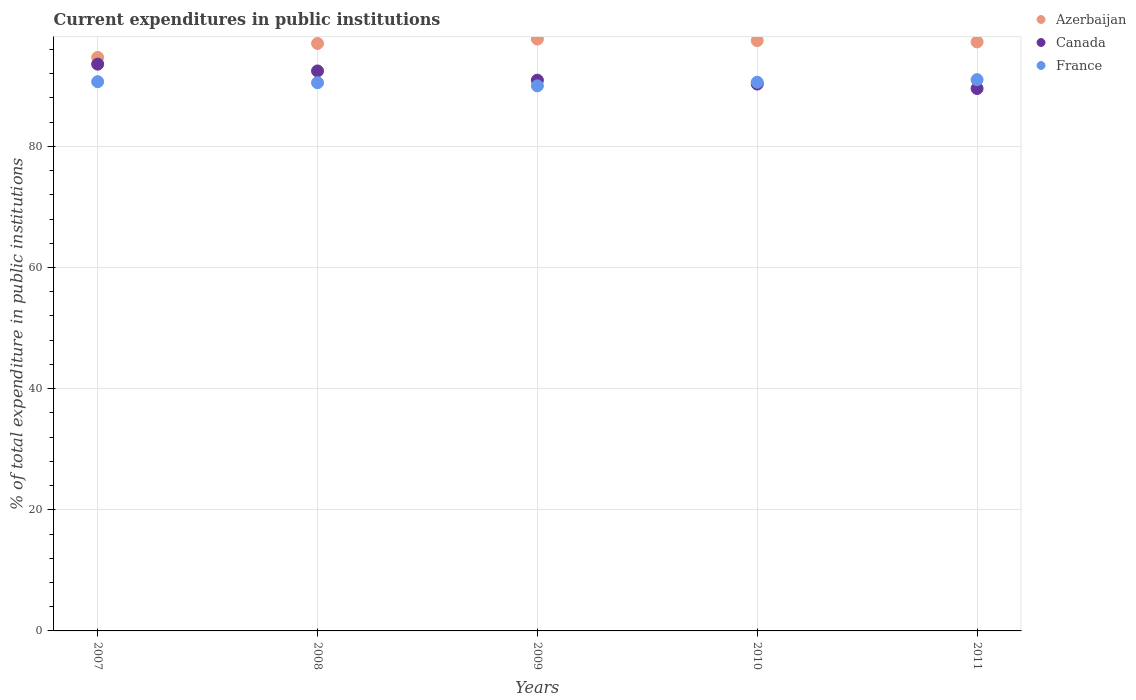Is the number of dotlines equal to the number of legend labels?
Give a very brief answer. Yes. What is the current expenditures in public institutions in Canada in 2008?
Your response must be concise. 92.45. Across all years, what is the maximum current expenditures in public institutions in Canada?
Keep it short and to the point. 93.57. Across all years, what is the minimum current expenditures in public institutions in Canada?
Offer a terse response. 89.55. What is the total current expenditures in public institutions in Canada in the graph?
Keep it short and to the point. 456.79. What is the difference between the current expenditures in public institutions in France in 2008 and that in 2011?
Your answer should be compact. -0.5. What is the difference between the current expenditures in public institutions in France in 2011 and the current expenditures in public institutions in Canada in 2010?
Provide a succinct answer. 0.72. What is the average current expenditures in public institutions in France per year?
Keep it short and to the point. 90.56. In the year 2008, what is the difference between the current expenditures in public institutions in France and current expenditures in public institutions in Azerbaijan?
Your answer should be compact. -6.48. In how many years, is the current expenditures in public institutions in France greater than 68 %?
Your response must be concise. 5. What is the ratio of the current expenditures in public institutions in Canada in 2007 to that in 2009?
Make the answer very short. 1.03. Is the current expenditures in public institutions in France in 2008 less than that in 2009?
Your answer should be very brief. No. Is the difference between the current expenditures in public institutions in France in 2010 and 2011 greater than the difference between the current expenditures in public institutions in Azerbaijan in 2010 and 2011?
Provide a succinct answer. No. What is the difference between the highest and the second highest current expenditures in public institutions in Canada?
Ensure brevity in your answer.  1.12. What is the difference between the highest and the lowest current expenditures in public institutions in Canada?
Give a very brief answer. 4.02. In how many years, is the current expenditures in public institutions in Canada greater than the average current expenditures in public institutions in Canada taken over all years?
Make the answer very short. 2. Is it the case that in every year, the sum of the current expenditures in public institutions in France and current expenditures in public institutions in Azerbaijan  is greater than the current expenditures in public institutions in Canada?
Your answer should be compact. Yes. Does the current expenditures in public institutions in Azerbaijan monotonically increase over the years?
Your response must be concise. No. Is the current expenditures in public institutions in France strictly less than the current expenditures in public institutions in Canada over the years?
Keep it short and to the point. No. How many years are there in the graph?
Offer a very short reply. 5. What is the difference between two consecutive major ticks on the Y-axis?
Offer a very short reply. 20. Where does the legend appear in the graph?
Keep it short and to the point. Top right. How many legend labels are there?
Your answer should be very brief. 3. How are the legend labels stacked?
Offer a terse response. Vertical. What is the title of the graph?
Provide a succinct answer. Current expenditures in public institutions. Does "Lesotho" appear as one of the legend labels in the graph?
Offer a terse response. No. What is the label or title of the X-axis?
Ensure brevity in your answer.  Years. What is the label or title of the Y-axis?
Ensure brevity in your answer.  % of total expenditure in public institutions. What is the % of total expenditure in public institutions in Azerbaijan in 2007?
Offer a terse response. 94.68. What is the % of total expenditure in public institutions in Canada in 2007?
Provide a succinct answer. 93.57. What is the % of total expenditure in public institutions in France in 2007?
Ensure brevity in your answer.  90.67. What is the % of total expenditure in public institutions in Azerbaijan in 2008?
Make the answer very short. 96.99. What is the % of total expenditure in public institutions in Canada in 2008?
Provide a succinct answer. 92.45. What is the % of total expenditure in public institutions in France in 2008?
Your answer should be compact. 90.51. What is the % of total expenditure in public institutions of Azerbaijan in 2009?
Offer a very short reply. 97.72. What is the % of total expenditure in public institutions of Canada in 2009?
Your answer should be very brief. 90.93. What is the % of total expenditure in public institutions in France in 2009?
Your response must be concise. 89.99. What is the % of total expenditure in public institutions of Azerbaijan in 2010?
Keep it short and to the point. 97.46. What is the % of total expenditure in public institutions in Canada in 2010?
Provide a succinct answer. 90.29. What is the % of total expenditure in public institutions in France in 2010?
Keep it short and to the point. 90.59. What is the % of total expenditure in public institutions of Azerbaijan in 2011?
Keep it short and to the point. 97.25. What is the % of total expenditure in public institutions of Canada in 2011?
Offer a terse response. 89.55. What is the % of total expenditure in public institutions in France in 2011?
Give a very brief answer. 91.01. Across all years, what is the maximum % of total expenditure in public institutions in Azerbaijan?
Provide a short and direct response. 97.72. Across all years, what is the maximum % of total expenditure in public institutions in Canada?
Offer a very short reply. 93.57. Across all years, what is the maximum % of total expenditure in public institutions of France?
Your answer should be compact. 91.01. Across all years, what is the minimum % of total expenditure in public institutions in Azerbaijan?
Provide a short and direct response. 94.68. Across all years, what is the minimum % of total expenditure in public institutions of Canada?
Provide a succinct answer. 89.55. Across all years, what is the minimum % of total expenditure in public institutions of France?
Your response must be concise. 89.99. What is the total % of total expenditure in public institutions in Azerbaijan in the graph?
Your answer should be very brief. 484.1. What is the total % of total expenditure in public institutions of Canada in the graph?
Give a very brief answer. 456.79. What is the total % of total expenditure in public institutions of France in the graph?
Provide a short and direct response. 452.78. What is the difference between the % of total expenditure in public institutions in Azerbaijan in 2007 and that in 2008?
Make the answer very short. -2.31. What is the difference between the % of total expenditure in public institutions in Canada in 2007 and that in 2008?
Offer a terse response. 1.12. What is the difference between the % of total expenditure in public institutions of France in 2007 and that in 2008?
Your answer should be compact. 0.17. What is the difference between the % of total expenditure in public institutions of Azerbaijan in 2007 and that in 2009?
Ensure brevity in your answer.  -3.04. What is the difference between the % of total expenditure in public institutions of Canada in 2007 and that in 2009?
Make the answer very short. 2.65. What is the difference between the % of total expenditure in public institutions in France in 2007 and that in 2009?
Offer a terse response. 0.68. What is the difference between the % of total expenditure in public institutions of Azerbaijan in 2007 and that in 2010?
Ensure brevity in your answer.  -2.78. What is the difference between the % of total expenditure in public institutions in Canada in 2007 and that in 2010?
Offer a very short reply. 3.28. What is the difference between the % of total expenditure in public institutions of France in 2007 and that in 2010?
Keep it short and to the point. 0.08. What is the difference between the % of total expenditure in public institutions in Azerbaijan in 2007 and that in 2011?
Keep it short and to the point. -2.57. What is the difference between the % of total expenditure in public institutions in Canada in 2007 and that in 2011?
Provide a short and direct response. 4.02. What is the difference between the % of total expenditure in public institutions in France in 2007 and that in 2011?
Keep it short and to the point. -0.34. What is the difference between the % of total expenditure in public institutions of Azerbaijan in 2008 and that in 2009?
Keep it short and to the point. -0.73. What is the difference between the % of total expenditure in public institutions in Canada in 2008 and that in 2009?
Your answer should be compact. 1.52. What is the difference between the % of total expenditure in public institutions in France in 2008 and that in 2009?
Provide a succinct answer. 0.52. What is the difference between the % of total expenditure in public institutions of Azerbaijan in 2008 and that in 2010?
Provide a short and direct response. -0.48. What is the difference between the % of total expenditure in public institutions of Canada in 2008 and that in 2010?
Offer a very short reply. 2.16. What is the difference between the % of total expenditure in public institutions in France in 2008 and that in 2010?
Provide a succinct answer. -0.08. What is the difference between the % of total expenditure in public institutions in Azerbaijan in 2008 and that in 2011?
Offer a very short reply. -0.26. What is the difference between the % of total expenditure in public institutions in Canada in 2008 and that in 2011?
Your answer should be very brief. 2.9. What is the difference between the % of total expenditure in public institutions in France in 2008 and that in 2011?
Keep it short and to the point. -0.5. What is the difference between the % of total expenditure in public institutions of Azerbaijan in 2009 and that in 2010?
Offer a very short reply. 0.25. What is the difference between the % of total expenditure in public institutions of Canada in 2009 and that in 2010?
Make the answer very short. 0.64. What is the difference between the % of total expenditure in public institutions of France in 2009 and that in 2010?
Your answer should be very brief. -0.6. What is the difference between the % of total expenditure in public institutions of Azerbaijan in 2009 and that in 2011?
Your answer should be compact. 0.47. What is the difference between the % of total expenditure in public institutions in Canada in 2009 and that in 2011?
Provide a short and direct response. 1.37. What is the difference between the % of total expenditure in public institutions of France in 2009 and that in 2011?
Your response must be concise. -1.02. What is the difference between the % of total expenditure in public institutions of Azerbaijan in 2010 and that in 2011?
Give a very brief answer. 0.22. What is the difference between the % of total expenditure in public institutions of Canada in 2010 and that in 2011?
Your response must be concise. 0.74. What is the difference between the % of total expenditure in public institutions of France in 2010 and that in 2011?
Provide a short and direct response. -0.42. What is the difference between the % of total expenditure in public institutions in Azerbaijan in 2007 and the % of total expenditure in public institutions in Canada in 2008?
Offer a very short reply. 2.23. What is the difference between the % of total expenditure in public institutions of Azerbaijan in 2007 and the % of total expenditure in public institutions of France in 2008?
Your answer should be compact. 4.17. What is the difference between the % of total expenditure in public institutions of Canada in 2007 and the % of total expenditure in public institutions of France in 2008?
Provide a short and direct response. 3.06. What is the difference between the % of total expenditure in public institutions in Azerbaijan in 2007 and the % of total expenditure in public institutions in Canada in 2009?
Keep it short and to the point. 3.75. What is the difference between the % of total expenditure in public institutions of Azerbaijan in 2007 and the % of total expenditure in public institutions of France in 2009?
Provide a succinct answer. 4.69. What is the difference between the % of total expenditure in public institutions in Canada in 2007 and the % of total expenditure in public institutions in France in 2009?
Your response must be concise. 3.58. What is the difference between the % of total expenditure in public institutions of Azerbaijan in 2007 and the % of total expenditure in public institutions of Canada in 2010?
Your answer should be very brief. 4.39. What is the difference between the % of total expenditure in public institutions in Azerbaijan in 2007 and the % of total expenditure in public institutions in France in 2010?
Keep it short and to the point. 4.09. What is the difference between the % of total expenditure in public institutions of Canada in 2007 and the % of total expenditure in public institutions of France in 2010?
Offer a terse response. 2.98. What is the difference between the % of total expenditure in public institutions of Azerbaijan in 2007 and the % of total expenditure in public institutions of Canada in 2011?
Your answer should be compact. 5.13. What is the difference between the % of total expenditure in public institutions of Azerbaijan in 2007 and the % of total expenditure in public institutions of France in 2011?
Offer a terse response. 3.67. What is the difference between the % of total expenditure in public institutions of Canada in 2007 and the % of total expenditure in public institutions of France in 2011?
Your answer should be compact. 2.56. What is the difference between the % of total expenditure in public institutions of Azerbaijan in 2008 and the % of total expenditure in public institutions of Canada in 2009?
Give a very brief answer. 6.06. What is the difference between the % of total expenditure in public institutions in Azerbaijan in 2008 and the % of total expenditure in public institutions in France in 2009?
Provide a succinct answer. 7. What is the difference between the % of total expenditure in public institutions in Canada in 2008 and the % of total expenditure in public institutions in France in 2009?
Ensure brevity in your answer.  2.46. What is the difference between the % of total expenditure in public institutions in Azerbaijan in 2008 and the % of total expenditure in public institutions in Canada in 2010?
Offer a very short reply. 6.7. What is the difference between the % of total expenditure in public institutions in Azerbaijan in 2008 and the % of total expenditure in public institutions in France in 2010?
Keep it short and to the point. 6.4. What is the difference between the % of total expenditure in public institutions in Canada in 2008 and the % of total expenditure in public institutions in France in 2010?
Your response must be concise. 1.86. What is the difference between the % of total expenditure in public institutions in Azerbaijan in 2008 and the % of total expenditure in public institutions in Canada in 2011?
Provide a short and direct response. 7.44. What is the difference between the % of total expenditure in public institutions in Azerbaijan in 2008 and the % of total expenditure in public institutions in France in 2011?
Provide a short and direct response. 5.97. What is the difference between the % of total expenditure in public institutions of Canada in 2008 and the % of total expenditure in public institutions of France in 2011?
Give a very brief answer. 1.44. What is the difference between the % of total expenditure in public institutions in Azerbaijan in 2009 and the % of total expenditure in public institutions in Canada in 2010?
Provide a succinct answer. 7.43. What is the difference between the % of total expenditure in public institutions of Azerbaijan in 2009 and the % of total expenditure in public institutions of France in 2010?
Provide a short and direct response. 7.13. What is the difference between the % of total expenditure in public institutions in Canada in 2009 and the % of total expenditure in public institutions in France in 2010?
Give a very brief answer. 0.33. What is the difference between the % of total expenditure in public institutions of Azerbaijan in 2009 and the % of total expenditure in public institutions of Canada in 2011?
Make the answer very short. 8.17. What is the difference between the % of total expenditure in public institutions of Azerbaijan in 2009 and the % of total expenditure in public institutions of France in 2011?
Ensure brevity in your answer.  6.7. What is the difference between the % of total expenditure in public institutions in Canada in 2009 and the % of total expenditure in public institutions in France in 2011?
Your response must be concise. -0.09. What is the difference between the % of total expenditure in public institutions in Azerbaijan in 2010 and the % of total expenditure in public institutions in Canada in 2011?
Ensure brevity in your answer.  7.91. What is the difference between the % of total expenditure in public institutions of Azerbaijan in 2010 and the % of total expenditure in public institutions of France in 2011?
Your answer should be compact. 6.45. What is the difference between the % of total expenditure in public institutions of Canada in 2010 and the % of total expenditure in public institutions of France in 2011?
Make the answer very short. -0.72. What is the average % of total expenditure in public institutions of Azerbaijan per year?
Make the answer very short. 96.82. What is the average % of total expenditure in public institutions in Canada per year?
Your response must be concise. 91.36. What is the average % of total expenditure in public institutions of France per year?
Give a very brief answer. 90.56. In the year 2007, what is the difference between the % of total expenditure in public institutions of Azerbaijan and % of total expenditure in public institutions of Canada?
Give a very brief answer. 1.11. In the year 2007, what is the difference between the % of total expenditure in public institutions in Azerbaijan and % of total expenditure in public institutions in France?
Give a very brief answer. 4.01. In the year 2007, what is the difference between the % of total expenditure in public institutions in Canada and % of total expenditure in public institutions in France?
Keep it short and to the point. 2.9. In the year 2008, what is the difference between the % of total expenditure in public institutions in Azerbaijan and % of total expenditure in public institutions in Canada?
Your response must be concise. 4.54. In the year 2008, what is the difference between the % of total expenditure in public institutions in Azerbaijan and % of total expenditure in public institutions in France?
Offer a terse response. 6.48. In the year 2008, what is the difference between the % of total expenditure in public institutions in Canada and % of total expenditure in public institutions in France?
Offer a very short reply. 1.94. In the year 2009, what is the difference between the % of total expenditure in public institutions of Azerbaijan and % of total expenditure in public institutions of Canada?
Your answer should be very brief. 6.79. In the year 2009, what is the difference between the % of total expenditure in public institutions of Azerbaijan and % of total expenditure in public institutions of France?
Ensure brevity in your answer.  7.73. In the year 2009, what is the difference between the % of total expenditure in public institutions of Canada and % of total expenditure in public institutions of France?
Your response must be concise. 0.94. In the year 2010, what is the difference between the % of total expenditure in public institutions in Azerbaijan and % of total expenditure in public institutions in Canada?
Provide a short and direct response. 7.18. In the year 2010, what is the difference between the % of total expenditure in public institutions in Azerbaijan and % of total expenditure in public institutions in France?
Your answer should be very brief. 6.87. In the year 2010, what is the difference between the % of total expenditure in public institutions in Canada and % of total expenditure in public institutions in France?
Keep it short and to the point. -0.3. In the year 2011, what is the difference between the % of total expenditure in public institutions of Azerbaijan and % of total expenditure in public institutions of Canada?
Keep it short and to the point. 7.7. In the year 2011, what is the difference between the % of total expenditure in public institutions of Azerbaijan and % of total expenditure in public institutions of France?
Provide a succinct answer. 6.24. In the year 2011, what is the difference between the % of total expenditure in public institutions of Canada and % of total expenditure in public institutions of France?
Your answer should be compact. -1.46. What is the ratio of the % of total expenditure in public institutions of Azerbaijan in 2007 to that in 2008?
Offer a very short reply. 0.98. What is the ratio of the % of total expenditure in public institutions of Canada in 2007 to that in 2008?
Offer a very short reply. 1.01. What is the ratio of the % of total expenditure in public institutions of Azerbaijan in 2007 to that in 2009?
Ensure brevity in your answer.  0.97. What is the ratio of the % of total expenditure in public institutions of Canada in 2007 to that in 2009?
Your response must be concise. 1.03. What is the ratio of the % of total expenditure in public institutions of France in 2007 to that in 2009?
Make the answer very short. 1.01. What is the ratio of the % of total expenditure in public institutions in Azerbaijan in 2007 to that in 2010?
Give a very brief answer. 0.97. What is the ratio of the % of total expenditure in public institutions in Canada in 2007 to that in 2010?
Offer a terse response. 1.04. What is the ratio of the % of total expenditure in public institutions of Azerbaijan in 2007 to that in 2011?
Your response must be concise. 0.97. What is the ratio of the % of total expenditure in public institutions in Canada in 2007 to that in 2011?
Your answer should be compact. 1.04. What is the ratio of the % of total expenditure in public institutions of France in 2007 to that in 2011?
Give a very brief answer. 1. What is the ratio of the % of total expenditure in public institutions in Canada in 2008 to that in 2009?
Give a very brief answer. 1.02. What is the ratio of the % of total expenditure in public institutions of France in 2008 to that in 2009?
Make the answer very short. 1.01. What is the ratio of the % of total expenditure in public institutions of Azerbaijan in 2008 to that in 2010?
Your answer should be compact. 1. What is the ratio of the % of total expenditure in public institutions of Canada in 2008 to that in 2010?
Offer a very short reply. 1.02. What is the ratio of the % of total expenditure in public institutions in Canada in 2008 to that in 2011?
Keep it short and to the point. 1.03. What is the ratio of the % of total expenditure in public institutions of France in 2008 to that in 2011?
Provide a short and direct response. 0.99. What is the ratio of the % of total expenditure in public institutions of Azerbaijan in 2009 to that in 2010?
Provide a succinct answer. 1. What is the ratio of the % of total expenditure in public institutions of Canada in 2009 to that in 2010?
Give a very brief answer. 1.01. What is the ratio of the % of total expenditure in public institutions in France in 2009 to that in 2010?
Provide a succinct answer. 0.99. What is the ratio of the % of total expenditure in public institutions of Azerbaijan in 2009 to that in 2011?
Offer a terse response. 1. What is the ratio of the % of total expenditure in public institutions of Canada in 2009 to that in 2011?
Provide a succinct answer. 1.02. What is the ratio of the % of total expenditure in public institutions of France in 2009 to that in 2011?
Your answer should be very brief. 0.99. What is the ratio of the % of total expenditure in public institutions of Canada in 2010 to that in 2011?
Make the answer very short. 1.01. What is the ratio of the % of total expenditure in public institutions in France in 2010 to that in 2011?
Provide a succinct answer. 1. What is the difference between the highest and the second highest % of total expenditure in public institutions of Azerbaijan?
Offer a terse response. 0.25. What is the difference between the highest and the second highest % of total expenditure in public institutions in Canada?
Keep it short and to the point. 1.12. What is the difference between the highest and the second highest % of total expenditure in public institutions in France?
Offer a terse response. 0.34. What is the difference between the highest and the lowest % of total expenditure in public institutions in Azerbaijan?
Your answer should be compact. 3.04. What is the difference between the highest and the lowest % of total expenditure in public institutions in Canada?
Provide a short and direct response. 4.02. What is the difference between the highest and the lowest % of total expenditure in public institutions in France?
Provide a succinct answer. 1.02. 